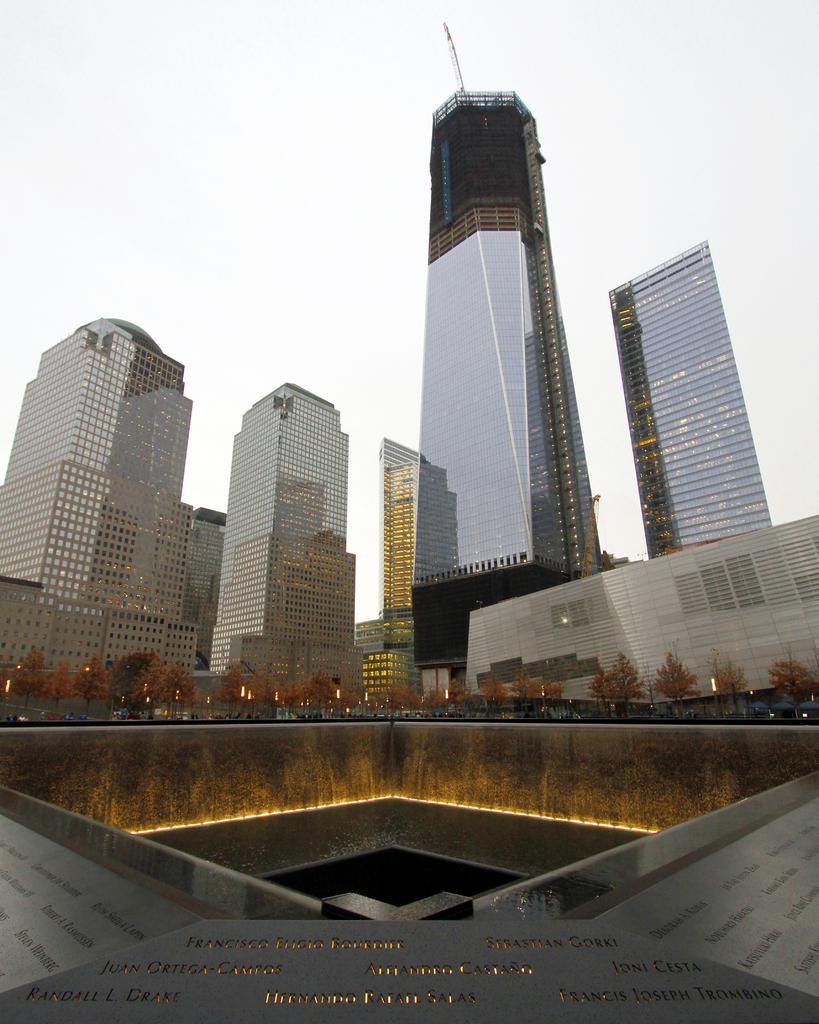Could you give a brief overview of what you see in this image? In this picture we can see so many buildings and some lights. 